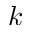Convert formula to latex. <formula><loc_0><loc_0><loc_500><loc_500>k</formula> 